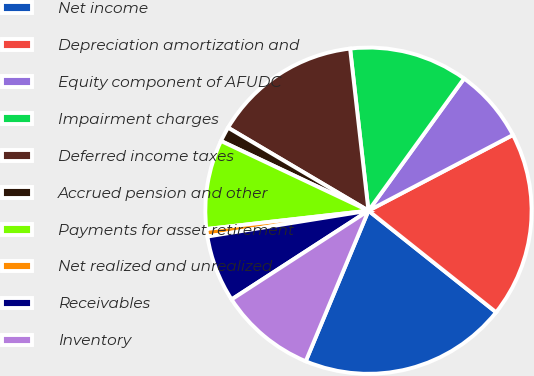<chart> <loc_0><loc_0><loc_500><loc_500><pie_chart><fcel>Net income<fcel>Depreciation amortization and<fcel>Equity component of AFUDC<fcel>Impairment charges<fcel>Deferred income taxes<fcel>Accrued pension and other<fcel>Payments for asset retirement<fcel>Net realized and unrealized<fcel>Receivables<fcel>Inventory<nl><fcel>20.58%<fcel>18.38%<fcel>7.35%<fcel>11.76%<fcel>14.7%<fcel>1.47%<fcel>8.82%<fcel>0.74%<fcel>6.62%<fcel>9.56%<nl></chart> 